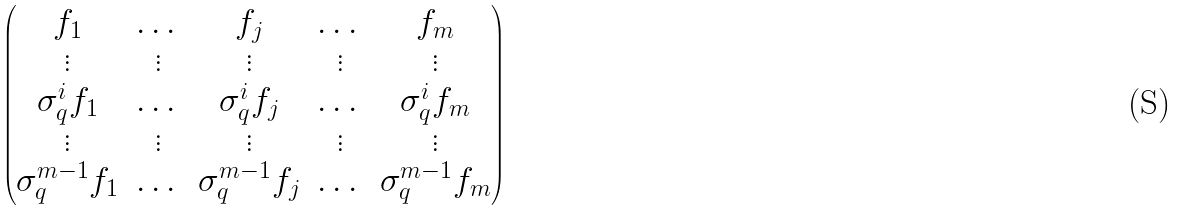Convert formula to latex. <formula><loc_0><loc_0><loc_500><loc_500>\begin{pmatrix} f _ { 1 } & \dots & f _ { j } & \dots & f _ { m } \\ \vdots & \vdots & \vdots & \vdots & \vdots \\ \sigma _ { q } ^ { i } f _ { 1 } & \dots & \sigma _ { q } ^ { i } f _ { j } & \dots & \sigma _ { q } ^ { i } f _ { m } \\ \vdots & \vdots & \vdots & \vdots & \vdots \\ \sigma _ { q } ^ { m - 1 } f _ { 1 } & \dots & \sigma _ { q } ^ { m - 1 } f _ { j } & \dots & \sigma _ { q } ^ { m - 1 } f _ { m } \end{pmatrix}</formula> 